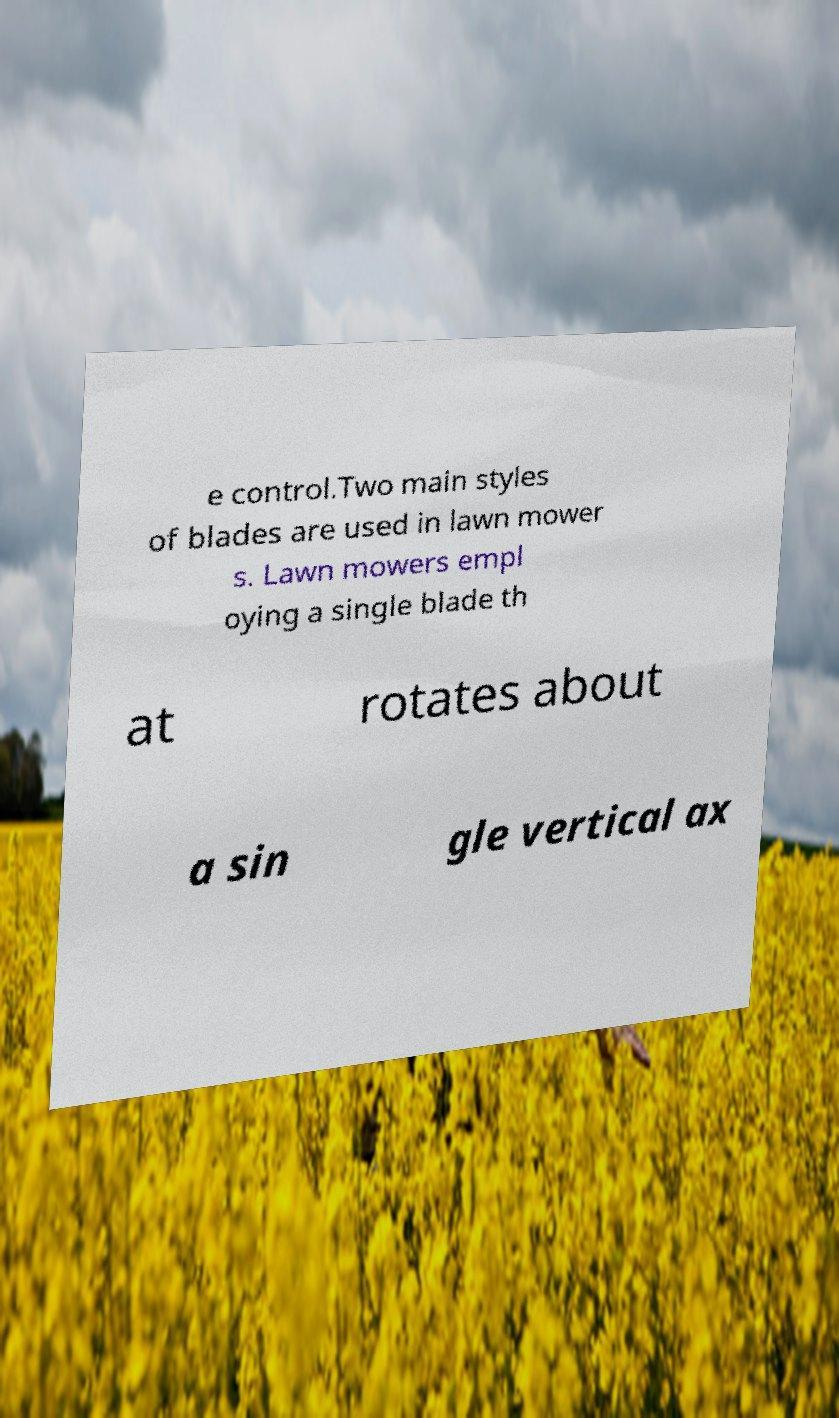Can you accurately transcribe the text from the provided image for me? e control.Two main styles of blades are used in lawn mower s. Lawn mowers empl oying a single blade th at rotates about a sin gle vertical ax 